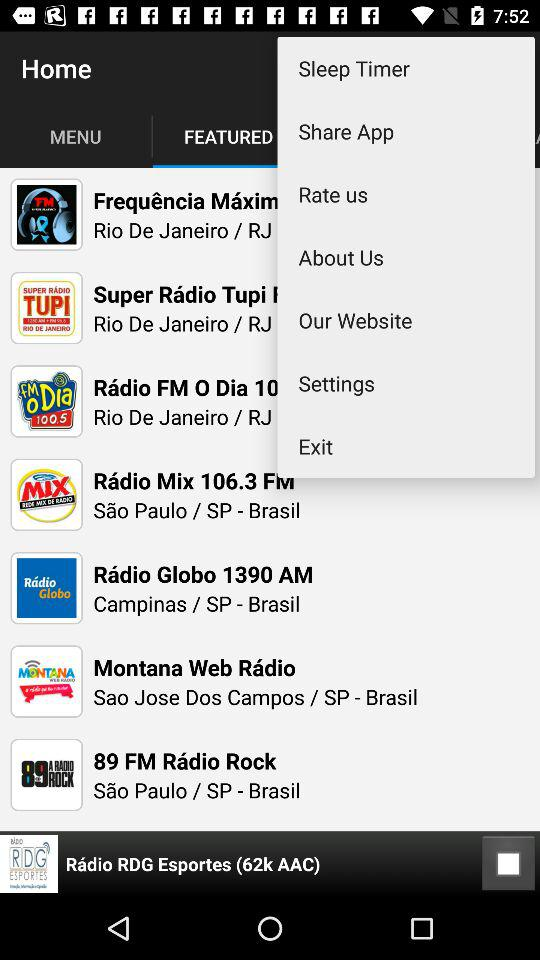Which tab is selected?
When the provided information is insufficient, respond with <no answer>. <no answer> 